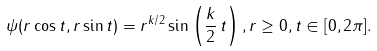<formula> <loc_0><loc_0><loc_500><loc_500>\psi ( r \cos t , r \sin t ) = r ^ { k / 2 } \sin \left ( \frac { k } { 2 } \, t \right ) , r \geq 0 , t \in [ 0 , 2 \pi ] .</formula> 